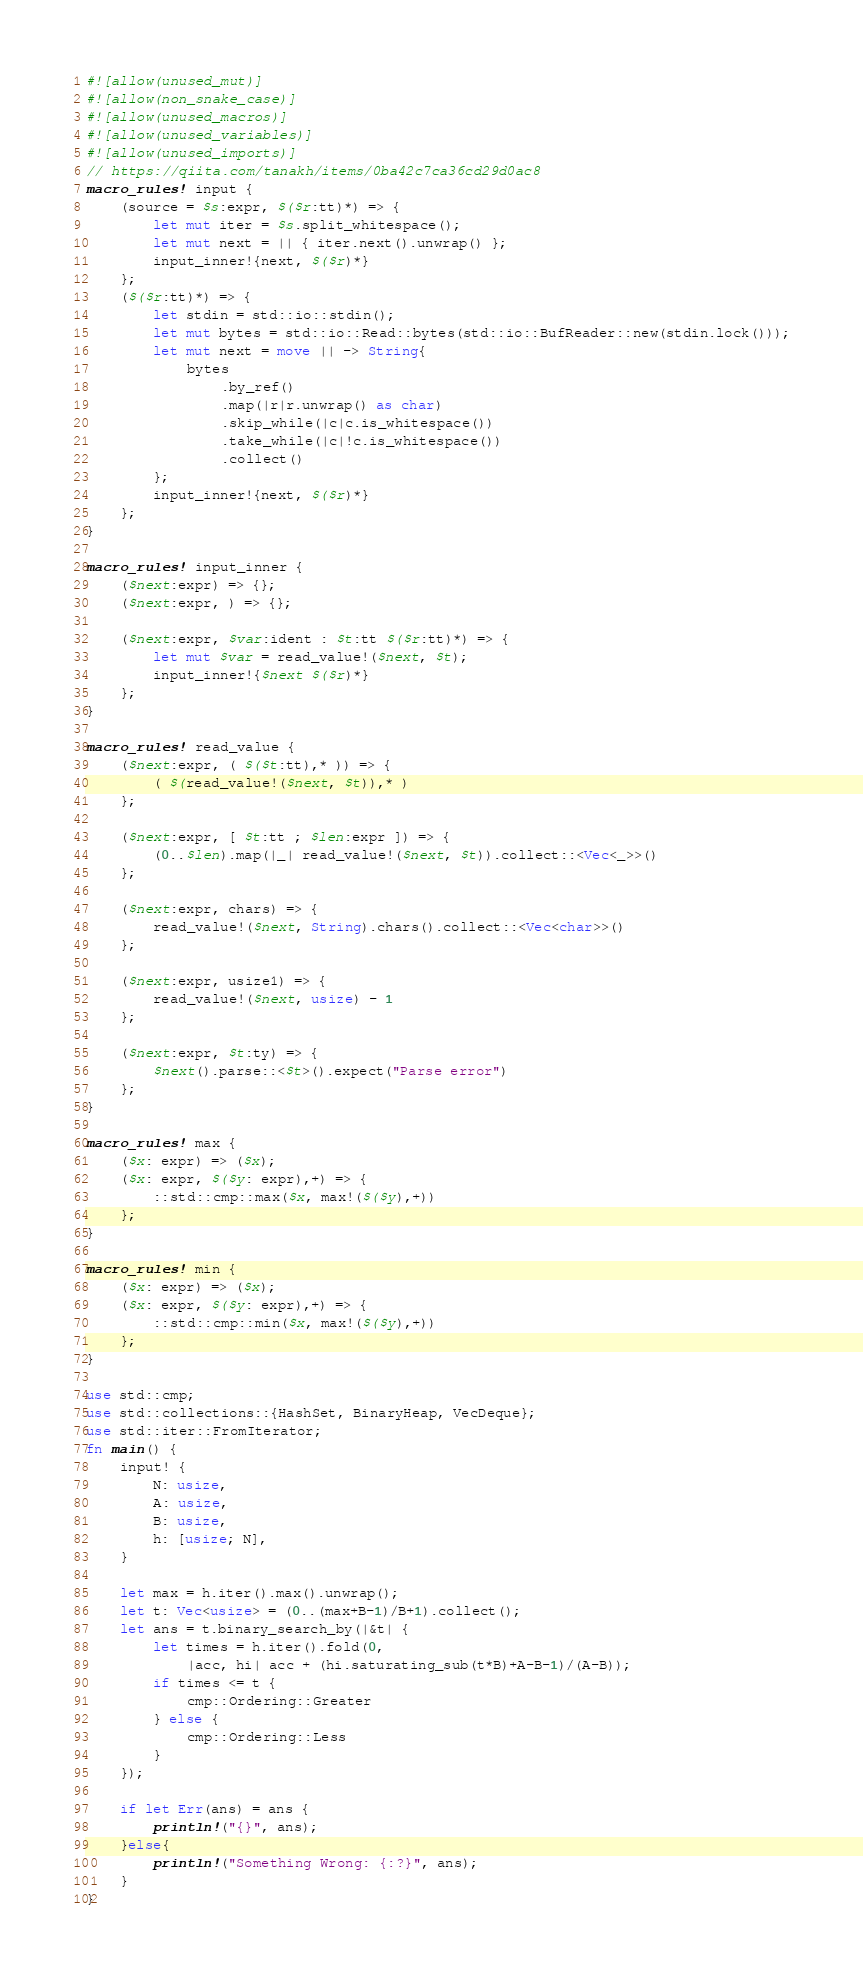Convert code to text. <code><loc_0><loc_0><loc_500><loc_500><_Rust_>#![allow(unused_mut)]
#![allow(non_snake_case)]
#![allow(unused_macros)]
#![allow(unused_variables)]
#![allow(unused_imports)]
// https://qiita.com/tanakh/items/0ba42c7ca36cd29d0ac8
macro_rules! input {
    (source = $s:expr, $($r:tt)*) => {
        let mut iter = $s.split_whitespace();
        let mut next = || { iter.next().unwrap() };
        input_inner!{next, $($r)*}
    };
    ($($r:tt)*) => {
        let stdin = std::io::stdin();
        let mut bytes = std::io::Read::bytes(std::io::BufReader::new(stdin.lock()));
        let mut next = move || -> String{
            bytes
                .by_ref()
                .map(|r|r.unwrap() as char)
                .skip_while(|c|c.is_whitespace())
                .take_while(|c|!c.is_whitespace())
                .collect()
        };
        input_inner!{next, $($r)*}
    };
}

macro_rules! input_inner {
    ($next:expr) => {};
    ($next:expr, ) => {};

    ($next:expr, $var:ident : $t:tt $($r:tt)*) => {
        let mut $var = read_value!($next, $t);
        input_inner!{$next $($r)*}
    };
}

macro_rules! read_value {
    ($next:expr, ( $($t:tt),* )) => {
        ( $(read_value!($next, $t)),* )
    };

    ($next:expr, [ $t:tt ; $len:expr ]) => {
        (0..$len).map(|_| read_value!($next, $t)).collect::<Vec<_>>()
    };

    ($next:expr, chars) => {
        read_value!($next, String).chars().collect::<Vec<char>>()
    };

    ($next:expr, usize1) => {
        read_value!($next, usize) - 1
    };

    ($next:expr, $t:ty) => {
        $next().parse::<$t>().expect("Parse error")
    };
}

macro_rules! max {
    ($x: expr) => ($x);
    ($x: expr, $($y: expr),+) => {
        ::std::cmp::max($x, max!($($y),+))
    };
}

macro_rules! min {
    ($x: expr) => ($x);
    ($x: expr, $($y: expr),+) => {
        ::std::cmp::min($x, max!($($y),+))
    };
}

use std::cmp;
use std::collections::{HashSet, BinaryHeap, VecDeque};
use std::iter::FromIterator;
fn main() {
    input! {
        N: usize, 
        A: usize,
        B: usize,
        h: [usize; N],
    }

    let max = h.iter().max().unwrap();
    let t: Vec<usize> = (0..(max+B-1)/B+1).collect();
    let ans = t.binary_search_by(|&t| {
        let times = h.iter().fold(0, 
            |acc, hi| acc + (hi.saturating_sub(t*B)+A-B-1)/(A-B));
        if times <= t {
            cmp::Ordering::Greater
        } else {
            cmp::Ordering::Less
        }
    });

    if let Err(ans) = ans {
        println!("{}", ans);
    }else{
        println!("Something Wrong: {:?}", ans);
    }
}</code> 